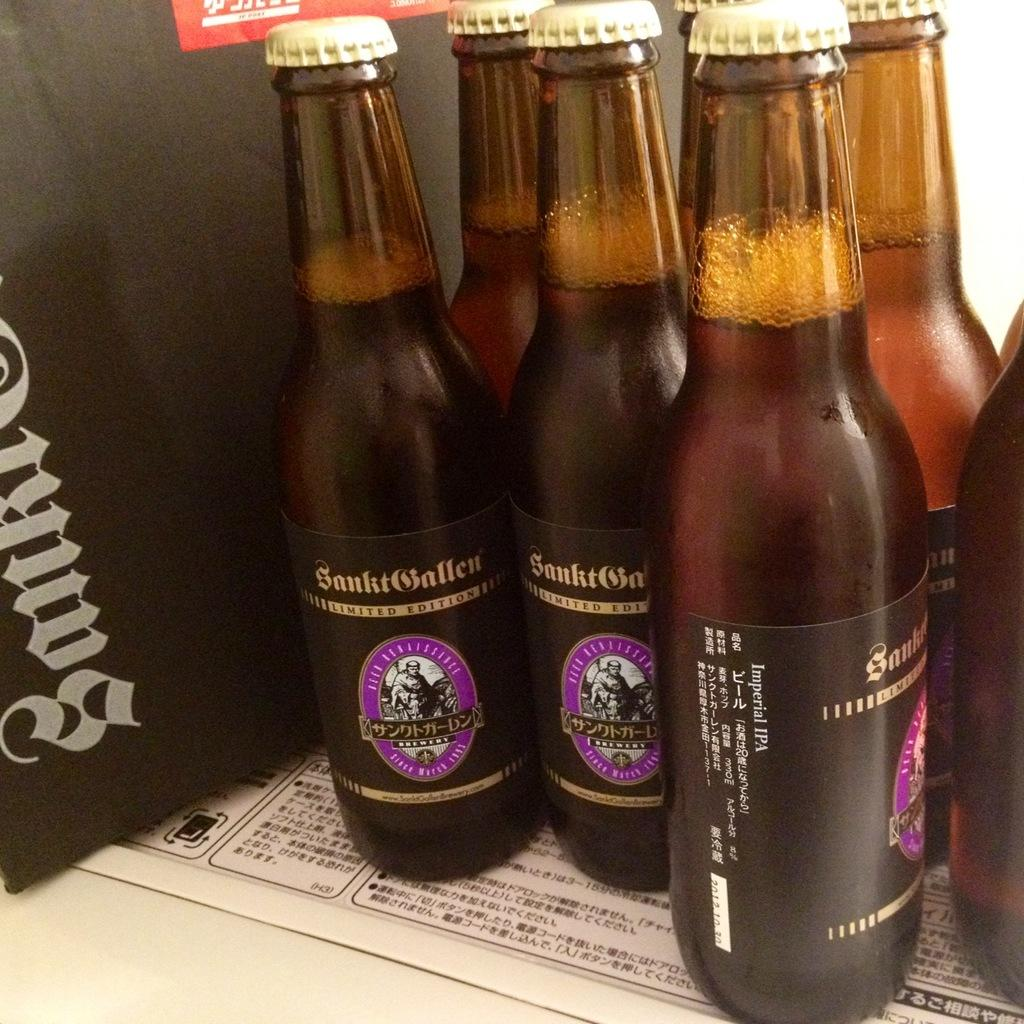What objects are visible in the image? There are bottles in the image. Where are the bottles located? The bottles are placed on a shelf. What is the shelf placed on in the image? The shelf is on a paper. How many toes can be seen on the servant in the image? There is no servant present in the image, and therefore no toes can be observed. What type of bird is perched on the wren in the image? There is no wren present in the image. 